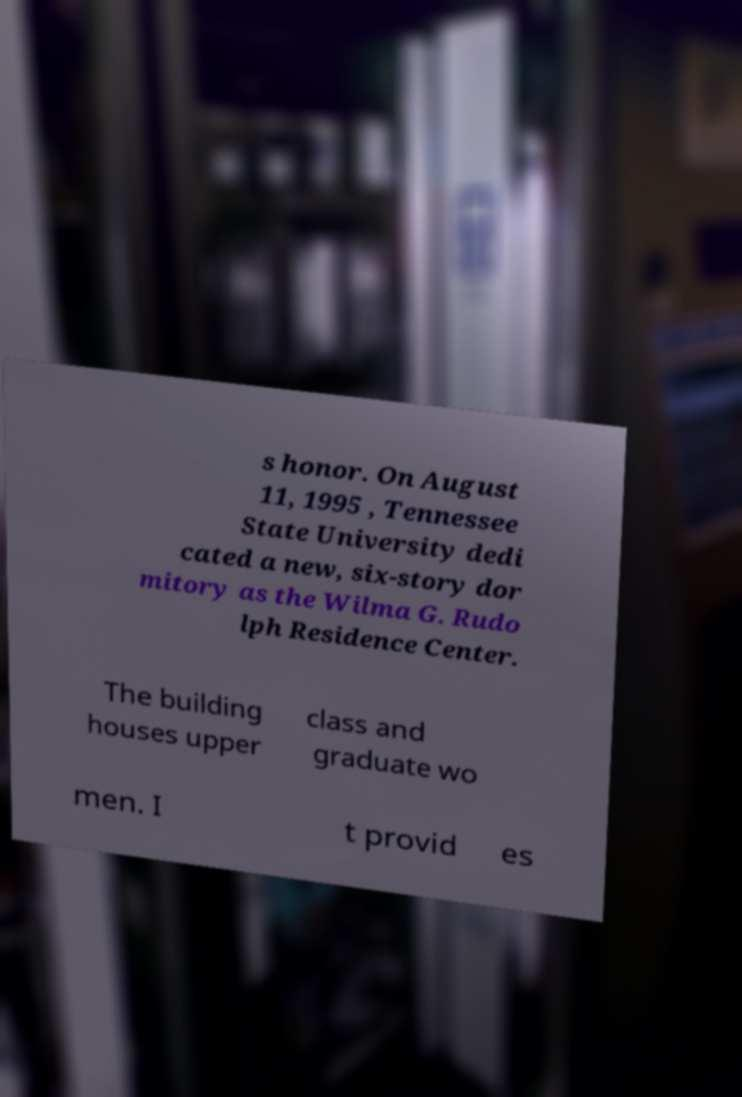For documentation purposes, I need the text within this image transcribed. Could you provide that? s honor. On August 11, 1995 , Tennessee State University dedi cated a new, six-story dor mitory as the Wilma G. Rudo lph Residence Center. The building houses upper class and graduate wo men. I t provid es 